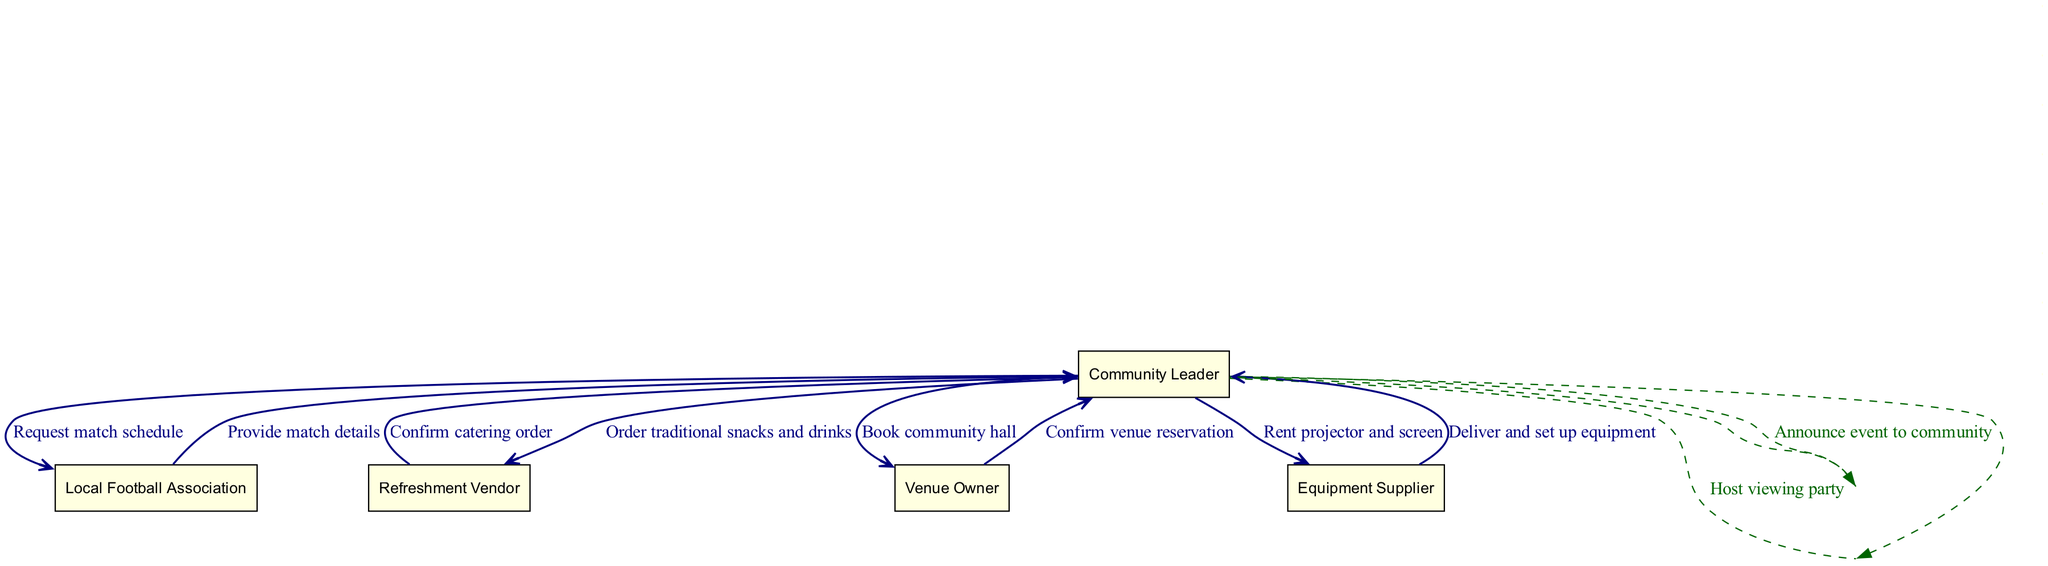What is the first message exchanged in the sequence? The first message is from the Community Leader to the Local Football Association, requesting the match schedule.
Answer: Request match schedule How many actors are involved in the sequence diagram? There are five actors listed in the diagram: Community Leader, Local Football Association, Venue Owner, Equipment Supplier, and Refreshment Vendor.
Answer: Five Which actor provides the match details? The Local Football Association is responsible for providing the match details to the Community Leader.
Answer: Local Football Association What is the last action taken by the Community Leader in this sequence? The last action is that the Community Leader hosts the viewing party after all preparations are completed.
Answer: Host viewing party Which vendor is responsible for providing traditional snacks and drinks? The Refreshment Vendor is responsible for supplying traditional snacks and drinks as ordered by the Community Leader.
Answer: Refreshment Vendor What message is sent between the Venue Owner and Community Leader after booking the hall? After booking the community hall, the Venue Owner confirms the venue reservation to the Community Leader.
Answer: Confirm venue reservation How many messages are exchanged between the Community Leader and Refreshment Vendor? Two messages are exchanged: the Community Leader orders snacks and drinks, and the Refreshment Vendor confirms the order.
Answer: Two What type of message is exchanged when the Community Leader announces the event to the community? This action is a self-message where the Community Leader announces the event to themselves before it is executed.
Answer: Self-message Which step depicts the delivery and setup of equipment? The step that depicts this message is from the Equipment Supplier to the Community Leader, stating the delivery and setup of equipment.
Answer: Deliver and set up equipment 